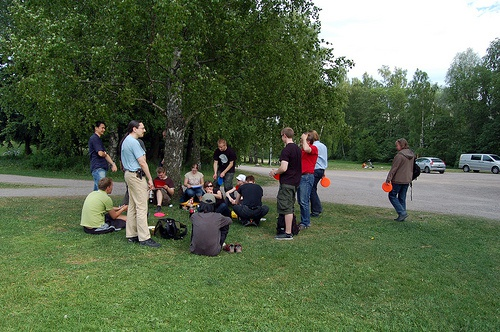Describe the objects in this image and their specific colors. I can see people in black, darkgray, tan, and lightblue tones, people in black, gray, and darkgray tones, people in black, gray, and darkgray tones, people in black, tan, khaki, and beige tones, and people in black, gray, and navy tones in this image. 